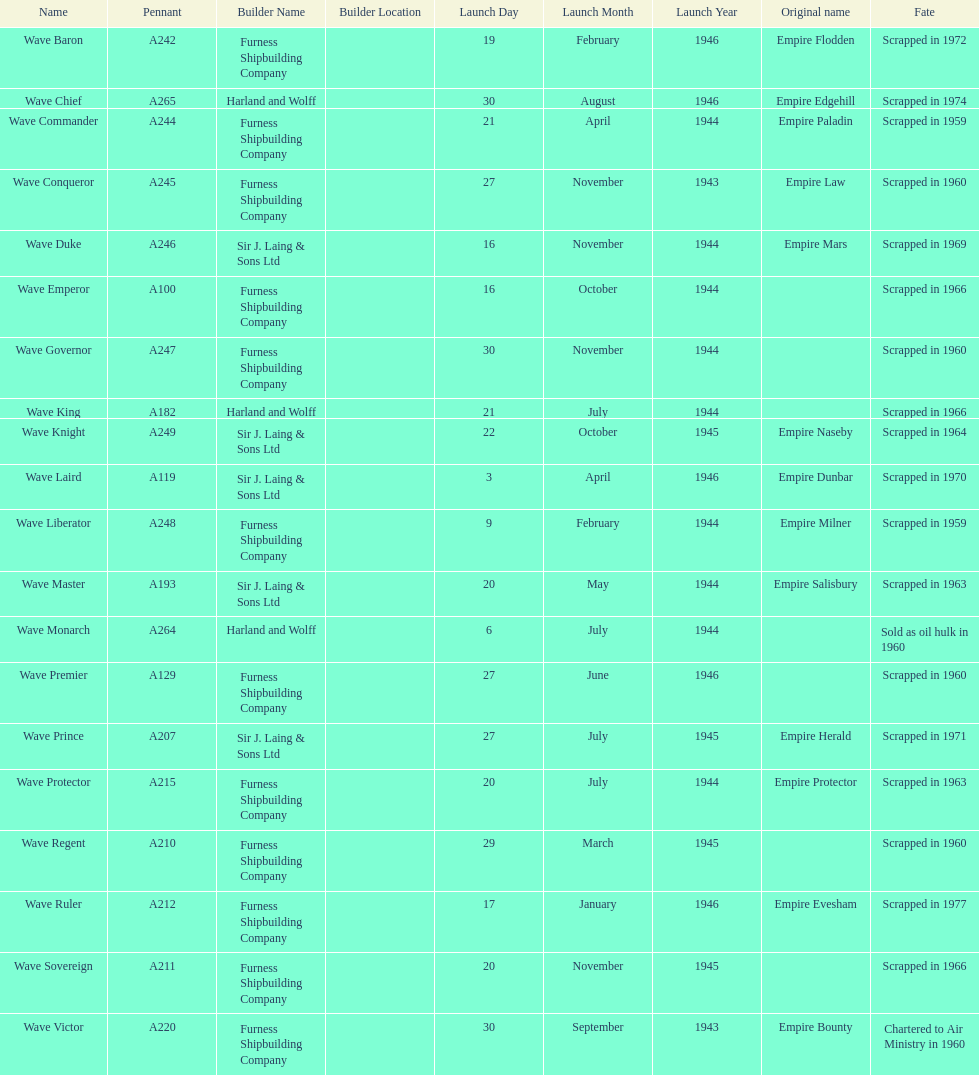What was the next wave class oiler after wave emperor? Wave Duke. 